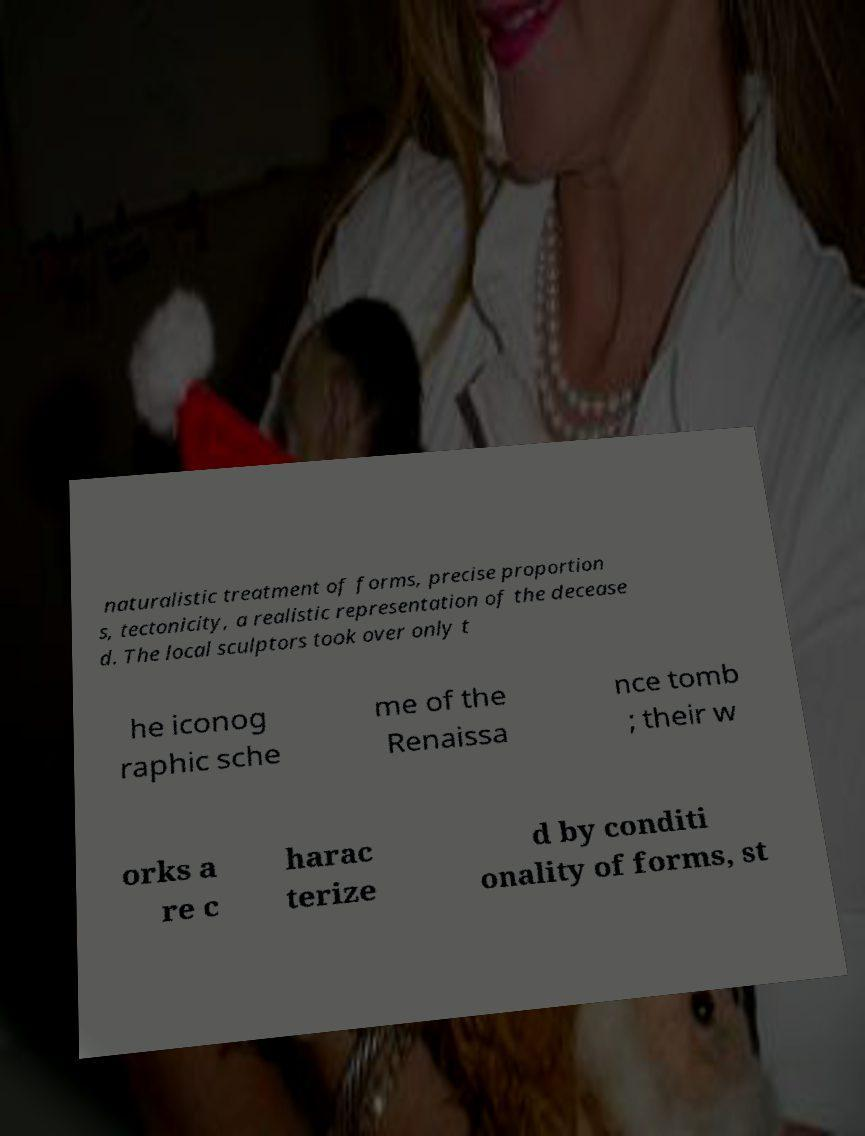Please read and relay the text visible in this image. What does it say? naturalistic treatment of forms, precise proportion s, tectonicity, a realistic representation of the decease d. The local sculptors took over only t he iconog raphic sche me of the Renaissa nce tomb ; their w orks a re c harac terize d by conditi onality of forms, st 